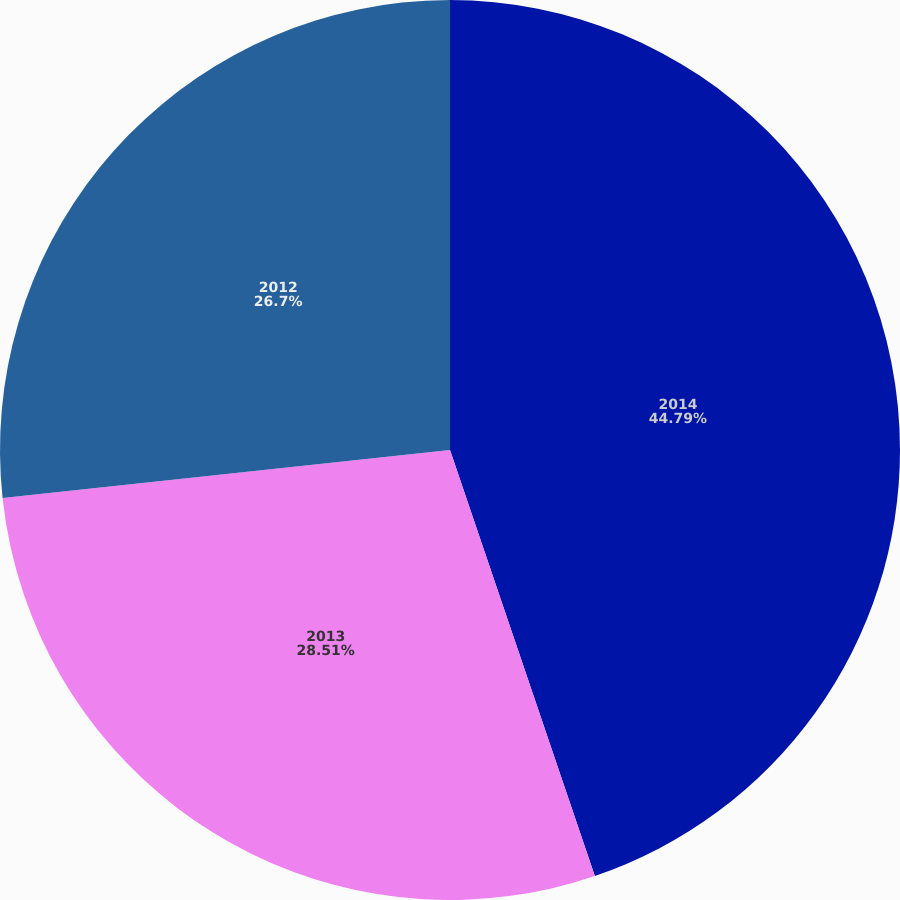Convert chart to OTSL. <chart><loc_0><loc_0><loc_500><loc_500><pie_chart><fcel>2014<fcel>2013<fcel>2012<nl><fcel>44.78%<fcel>28.51%<fcel>26.7%<nl></chart> 